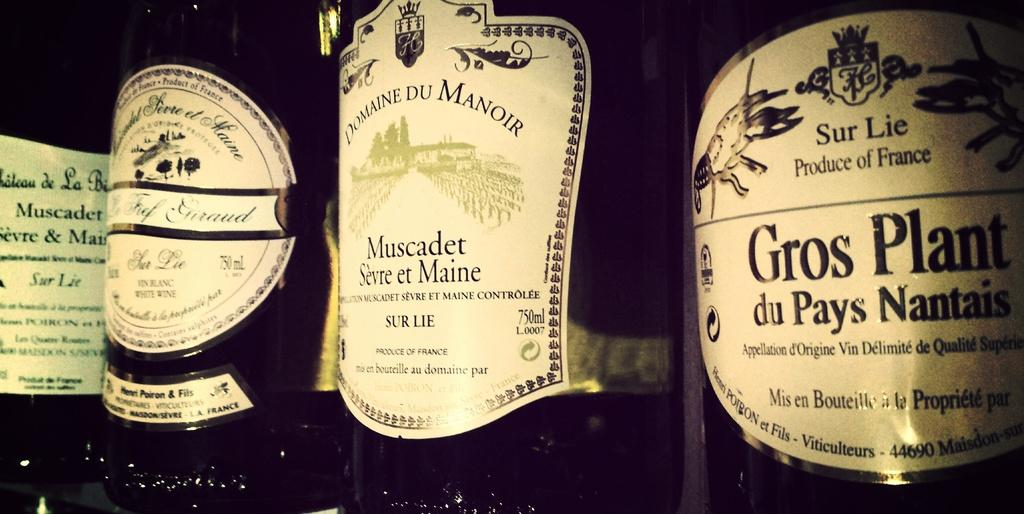<image>
Summarize the visual content of the image. four bottles of wine, one of which is Gros Plant 